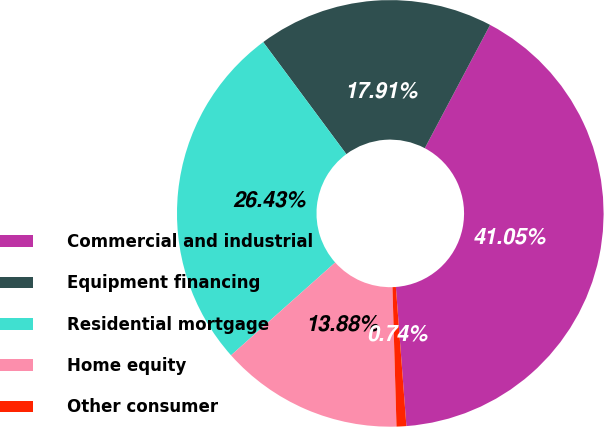Convert chart. <chart><loc_0><loc_0><loc_500><loc_500><pie_chart><fcel>Commercial and industrial<fcel>Equipment financing<fcel>Residential mortgage<fcel>Home equity<fcel>Other consumer<nl><fcel>41.05%<fcel>17.91%<fcel>26.43%<fcel>13.88%<fcel>0.74%<nl></chart> 